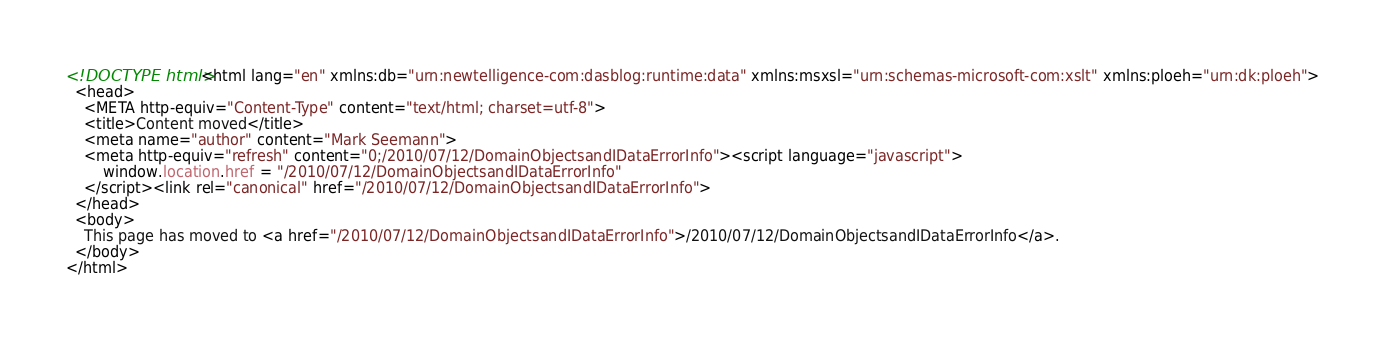<code> <loc_0><loc_0><loc_500><loc_500><_HTML_><!DOCTYPE html><html lang="en" xmlns:db="urn:newtelligence-com:dasblog:runtime:data" xmlns:msxsl="urn:schemas-microsoft-com:xslt" xmlns:ploeh="urn:dk:ploeh">
  <head>
    <META http-equiv="Content-Type" content="text/html; charset=utf-8">
    <title>Content moved</title>
    <meta name="author" content="Mark Seemann">
    <meta http-equiv="refresh" content="0;/2010/07/12/DomainObjectsandIDataErrorInfo"><script language="javascript">
        window.location.href = "/2010/07/12/DomainObjectsandIDataErrorInfo"
    </script><link rel="canonical" href="/2010/07/12/DomainObjectsandIDataErrorInfo">
  </head>
  <body>
    This page has moved to <a href="/2010/07/12/DomainObjectsandIDataErrorInfo">/2010/07/12/DomainObjectsandIDataErrorInfo</a>.
  </body>
</html></code> 